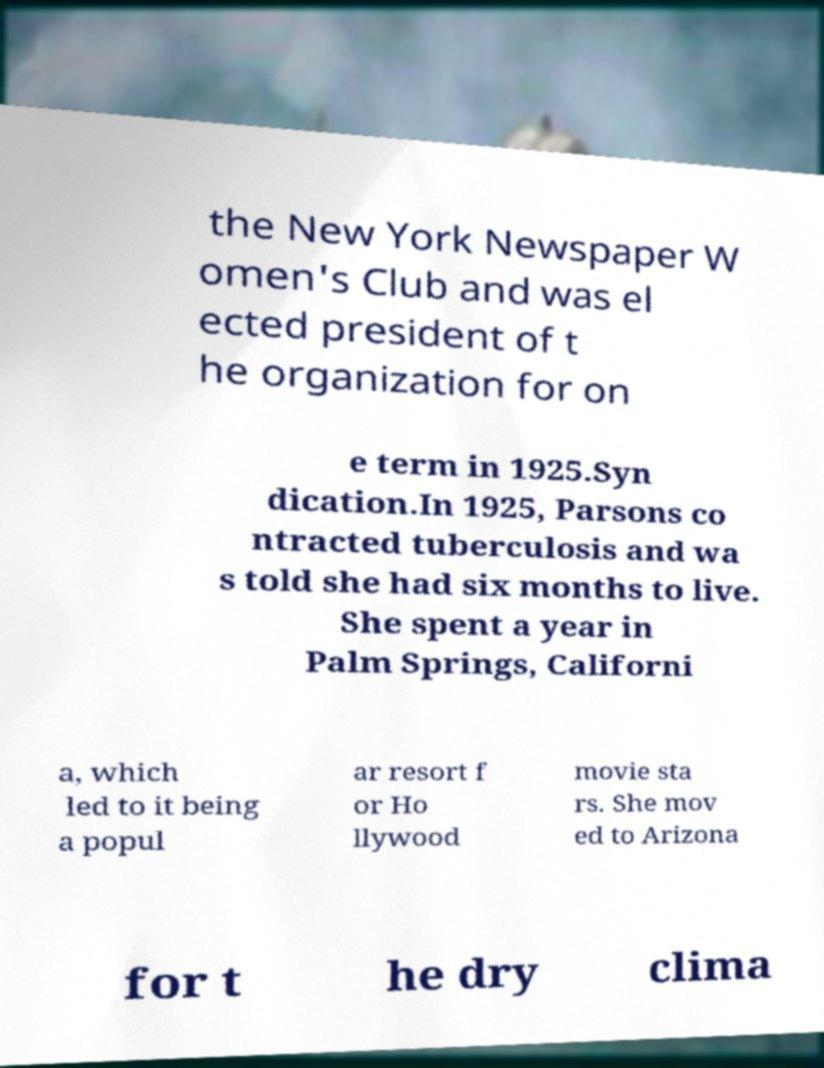What messages or text are displayed in this image? I need them in a readable, typed format. the New York Newspaper W omen's Club and was el ected president of t he organization for on e term in 1925.Syn dication.In 1925, Parsons co ntracted tuberculosis and wa s told she had six months to live. She spent a year in Palm Springs, Californi a, which led to it being a popul ar resort f or Ho llywood movie sta rs. She mov ed to Arizona for t he dry clima 